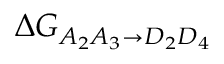<formula> <loc_0><loc_0><loc_500><loc_500>\Delta G _ { A _ { 2 } A _ { 3 } \rightarrow D _ { 2 } D _ { 4 } }</formula> 